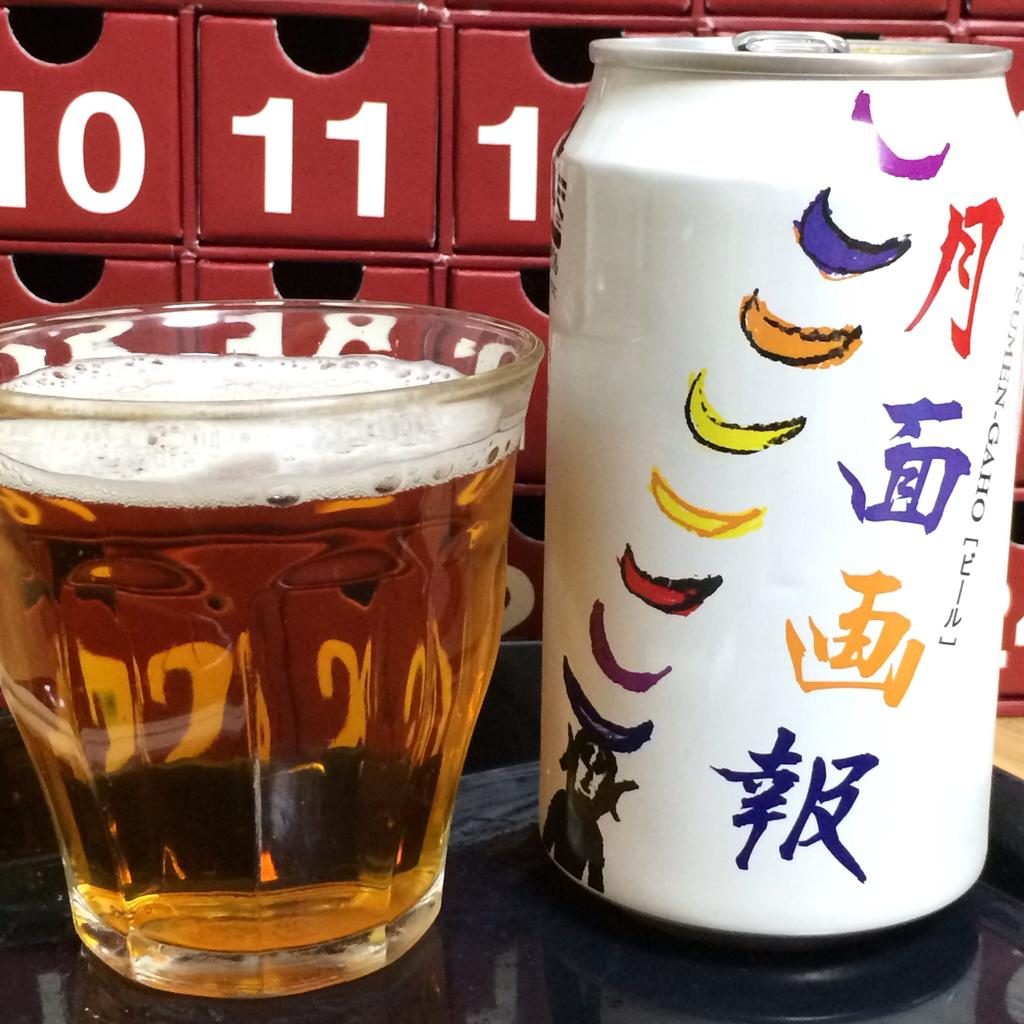<image>
Present a compact description of the photo's key features. White can that says "Gaho" next to a cup of beer. 